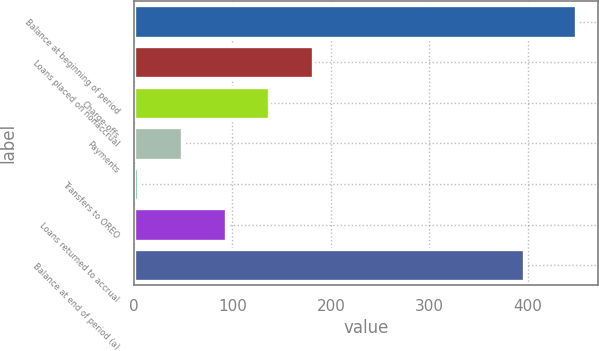Convert chart to OTSL. <chart><loc_0><loc_0><loc_500><loc_500><bar_chart><fcel>Balance at beginning of period<fcel>Loans placed on nonaccrual<fcel>Charge-offs<fcel>Payments<fcel>Transfers to OREO<fcel>Loans returned to accrual<fcel>Balance at end of period (a)<nl><fcel>449<fcel>182<fcel>137.5<fcel>48.5<fcel>4<fcel>93<fcel>396<nl></chart> 